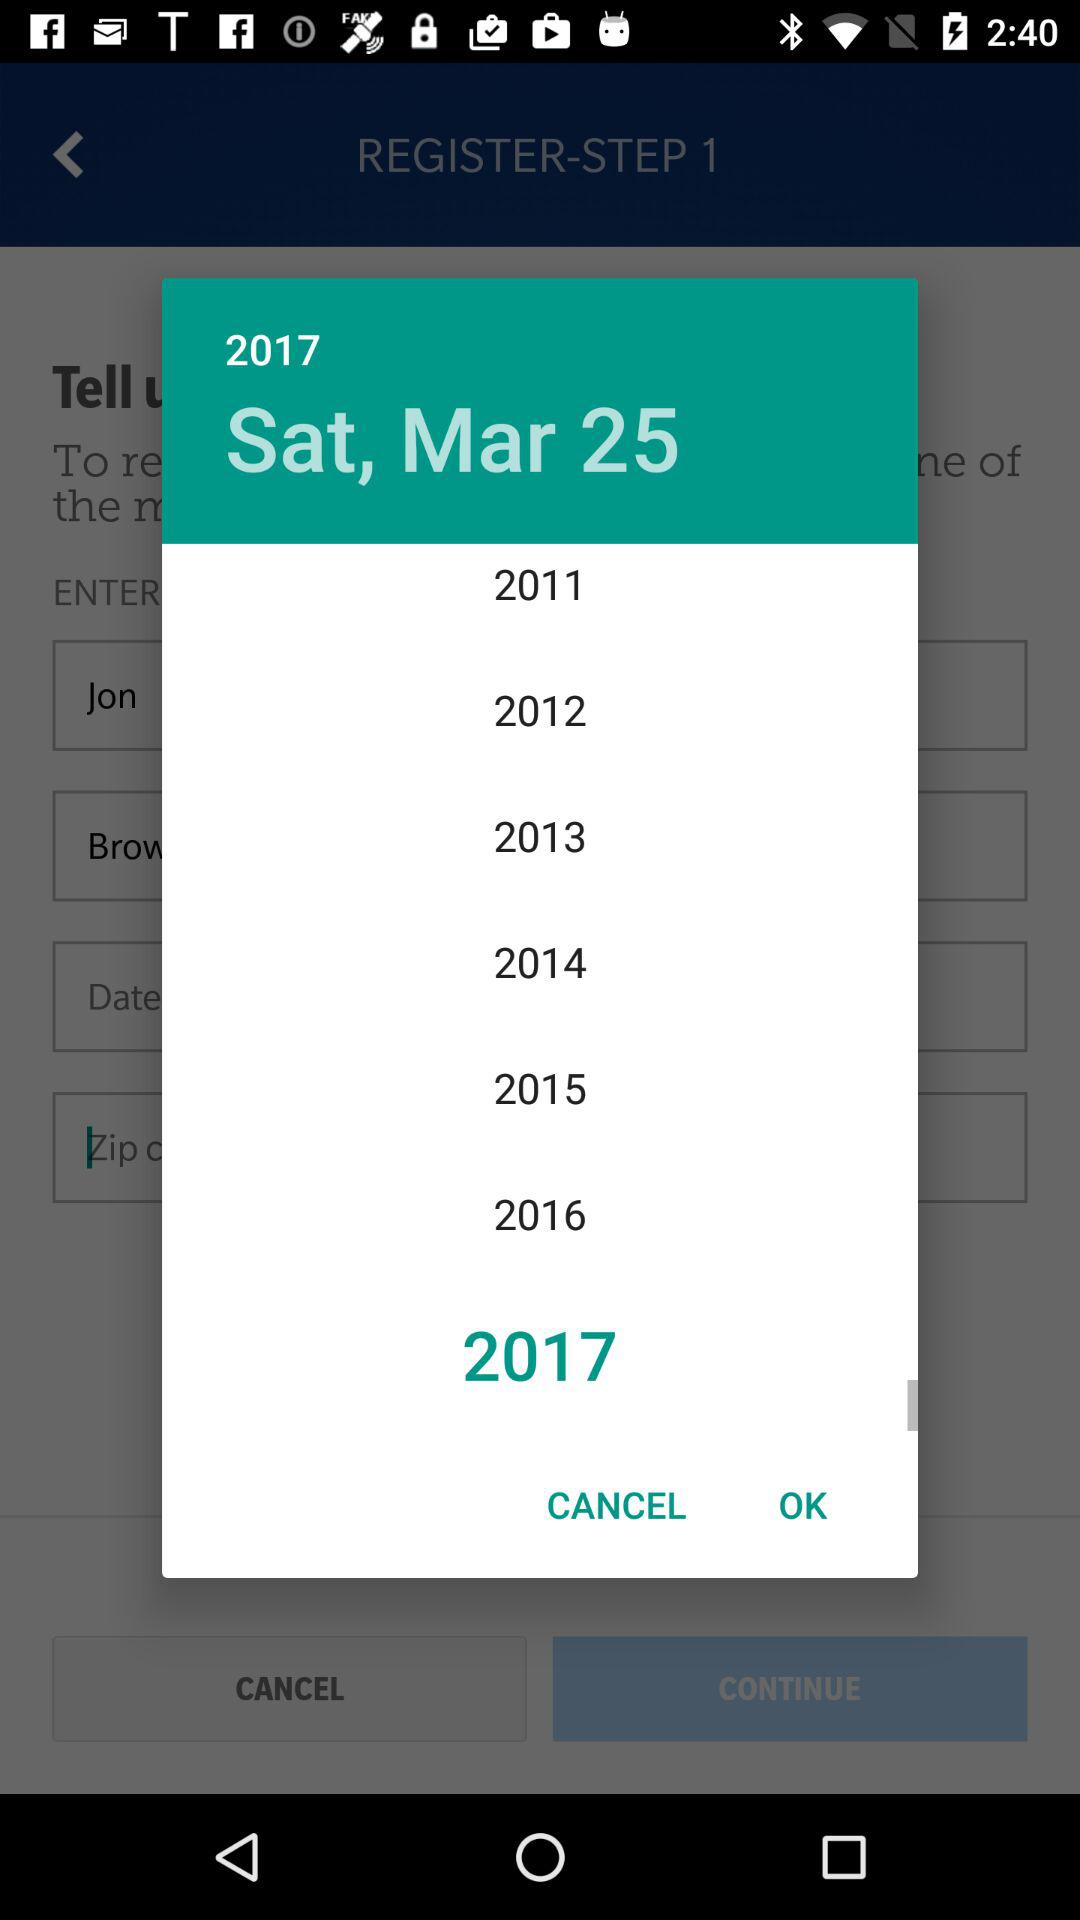What is the day on March 25, 2017? The day is Saturday. 